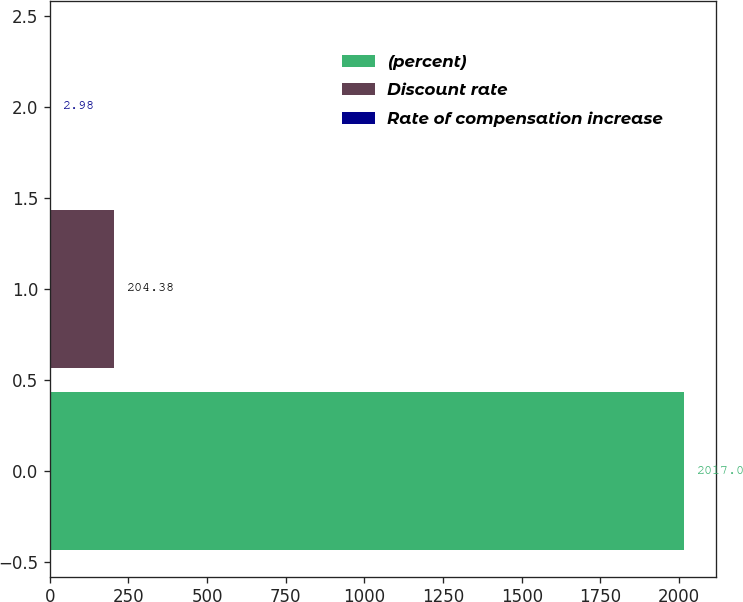Convert chart to OTSL. <chart><loc_0><loc_0><loc_500><loc_500><bar_chart><fcel>(percent)<fcel>Discount rate<fcel>Rate of compensation increase<nl><fcel>2017<fcel>204.38<fcel>2.98<nl></chart> 